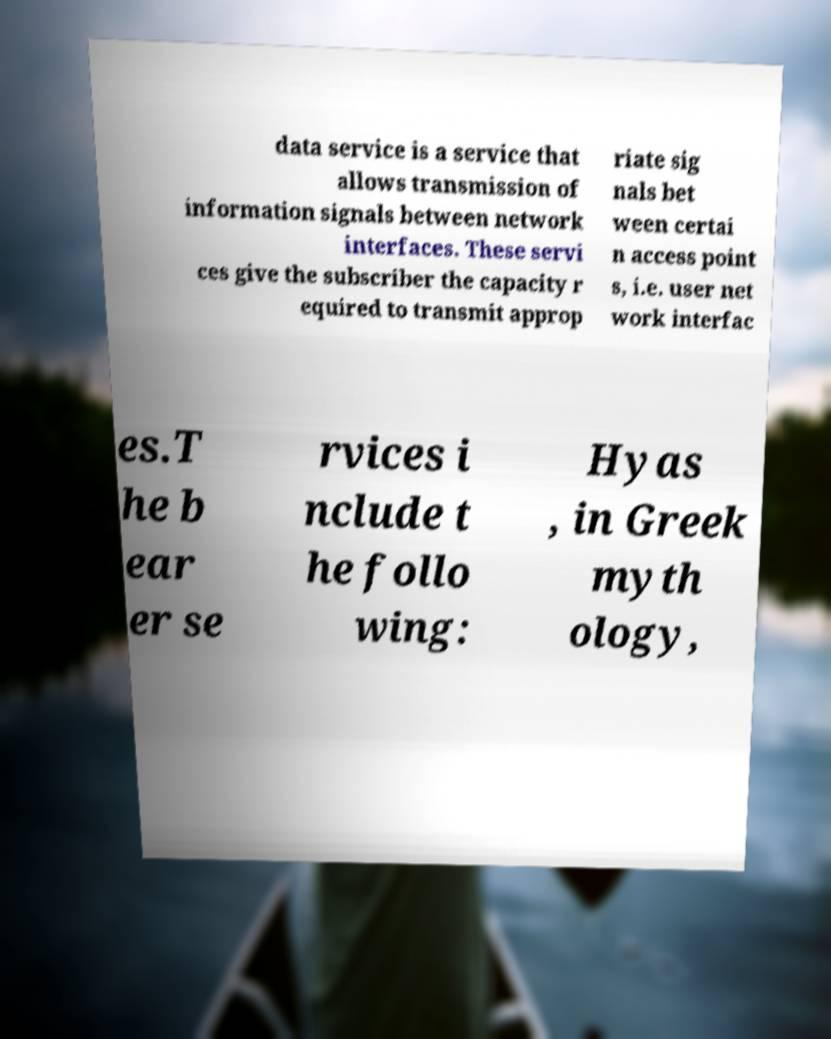There's text embedded in this image that I need extracted. Can you transcribe it verbatim? data service is a service that allows transmission of information signals between network interfaces. These servi ces give the subscriber the capacity r equired to transmit approp riate sig nals bet ween certai n access point s, i.e. user net work interfac es.T he b ear er se rvices i nclude t he follo wing: Hyas , in Greek myth ology, 